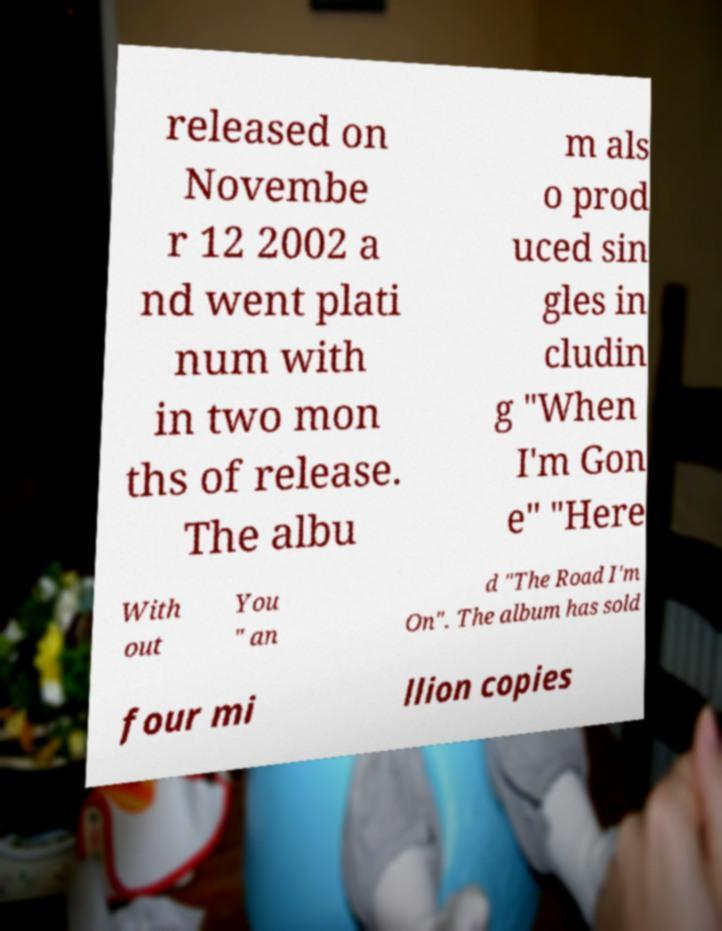Can you accurately transcribe the text from the provided image for me? released on Novembe r 12 2002 a nd went plati num with in two mon ths of release. The albu m als o prod uced sin gles in cludin g "When I'm Gon e" "Here With out You " an d "The Road I'm On". The album has sold four mi llion copies 